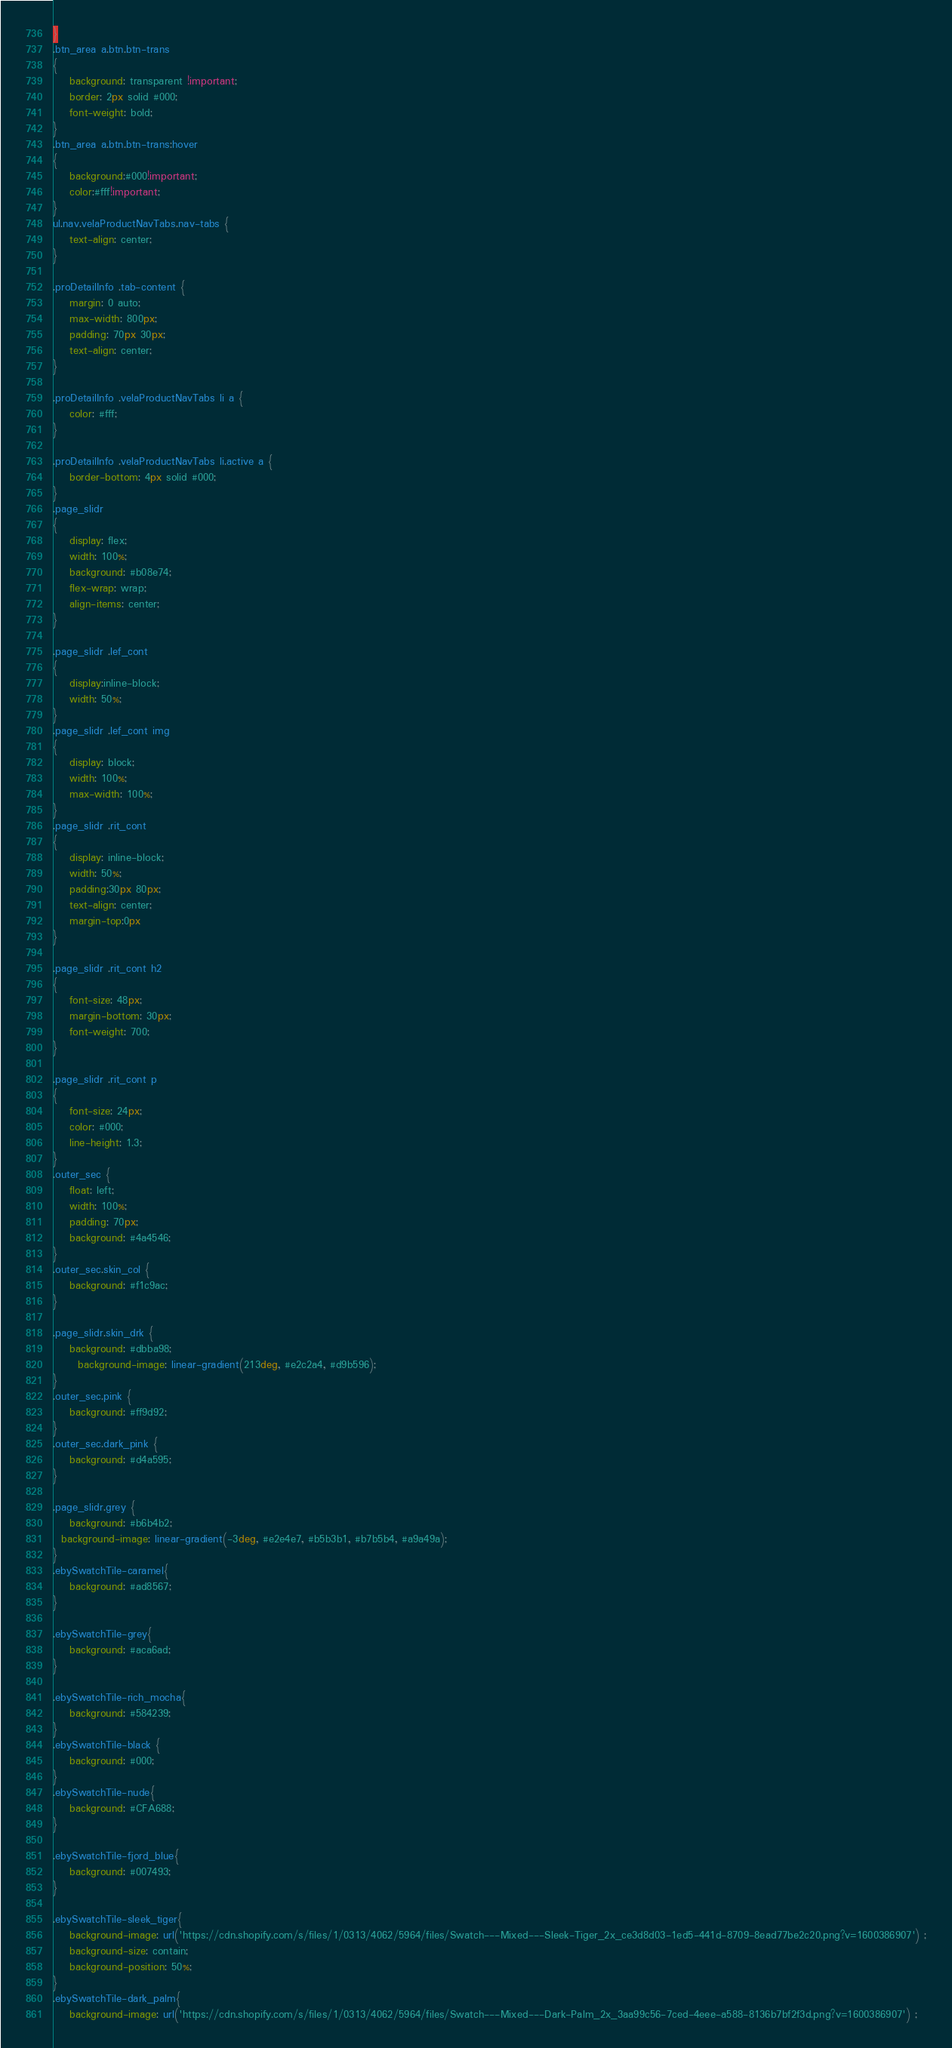Convert code to text. <code><loc_0><loc_0><loc_500><loc_500><_CSS_>}
.btn_area a.btn.btn-trans
{
    background: transparent !important;
    border: 2px solid #000;
    font-weight: bold;
}
.btn_area a.btn.btn-trans:hover
{
	background:#000!important;
	color:#fff!important;
}
ul.nav.velaProductNavTabs.nav-tabs {
    text-align: center;
}

.proDetailInfo .tab-content {
    margin: 0 auto;
    max-width: 800px;
    padding: 70px 30px;
    text-align: center;
}

.proDetailInfo .velaProductNavTabs li a {
    color: #fff;
}

.proDetailInfo .velaProductNavTabs li.active a {
    border-bottom: 4px solid #000;
}
.page_slidr
{
	display: flex;
    width: 100%;
    background: #b08e74;
    flex-wrap: wrap;
    align-items: center;
}

.page_slidr .lef_cont
{
    display:inline-block;
    width: 50%;
}
.page_slidr .lef_cont img
{
    display: block;
    width: 100%;
    max-width: 100%;
}
.page_slidr .rit_cont
{
    display: inline-block;
    width: 50%;
    padding:30px 80px;
    text-align: center;
	margin-top:0px
}

.page_slidr .rit_cont h2
{
    font-size: 48px;
    margin-bottom: 30px;
    font-weight: 700;
}

.page_slidr .rit_cont p
{
    font-size: 24px;
    color: #000;
    line-height: 1.3;
}
.outer_sec {
    float: left;
    width: 100%;
    padding: 70px;
    background: #4a4546;
}
.outer_sec.skin_col {
    background: #f1c9ac;
}

.page_slidr.skin_drk {
    background: #dbba98;
      background-image: linear-gradient(213deg, #e2c2a4, #d9b596);
}
.outer_sec.pink {
    background: #ff9d92;
}
.outer_sec.dark_pink {
    background: #d4a595;
}

.page_slidr.grey {
    background: #b6b4b2;
  background-image: linear-gradient(-3deg, #e2e4e7, #b5b3b1, #b7b5b4, #a9a49a);
}
.ebySwatchTile-caramel{
	background: #ad8567;
}
 
.ebySwatchTile-grey{
	background: #aca6ad;  	
}
 
.ebySwatchTile-rich_mocha{
  	background: #584239;
}
.ebySwatchTile-black {
	background: #000;
}
.ebySwatchTile-nude{
	background: #CFA688;
}
 
.ebySwatchTile-fjord_blue{
  	background: #007493;
}
 
.ebySwatchTile-sleek_tiger{
	background-image: url('https://cdn.shopify.com/s/files/1/0313/4062/5964/files/Swatch---Mixed---Sleek-Tiger_2x_ce3d8d03-1ed5-441d-8709-8ead77be2c20.png?v=1600386907') ;
    background-size: contain;
  	background-position: 50%; 
}
.ebySwatchTile-dark_palm{
	background-image: url('https://cdn.shopify.com/s/files/1/0313/4062/5964/files/Swatch---Mixed---Dark-Palm_2x_3aa99c56-7ced-4eee-a588-8136b7bf2f3d.png?v=1600386907') ;</code> 